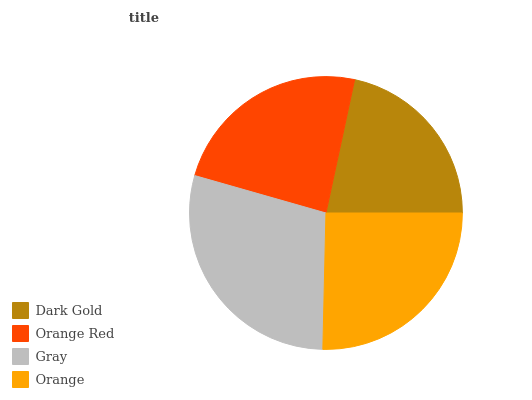Is Dark Gold the minimum?
Answer yes or no. Yes. Is Gray the maximum?
Answer yes or no. Yes. Is Orange Red the minimum?
Answer yes or no. No. Is Orange Red the maximum?
Answer yes or no. No. Is Orange Red greater than Dark Gold?
Answer yes or no. Yes. Is Dark Gold less than Orange Red?
Answer yes or no. Yes. Is Dark Gold greater than Orange Red?
Answer yes or no. No. Is Orange Red less than Dark Gold?
Answer yes or no. No. Is Orange the high median?
Answer yes or no. Yes. Is Orange Red the low median?
Answer yes or no. Yes. Is Gray the high median?
Answer yes or no. No. Is Dark Gold the low median?
Answer yes or no. No. 